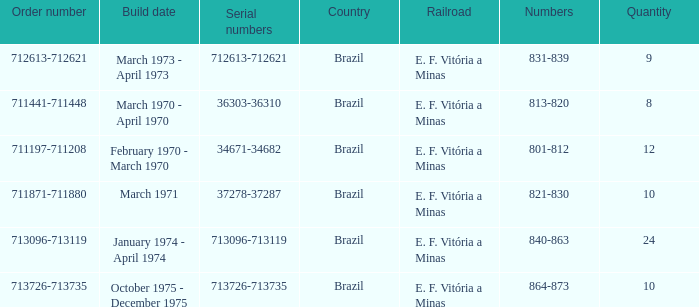The order number 713726-713735 has what serial number? 713726-713735. 